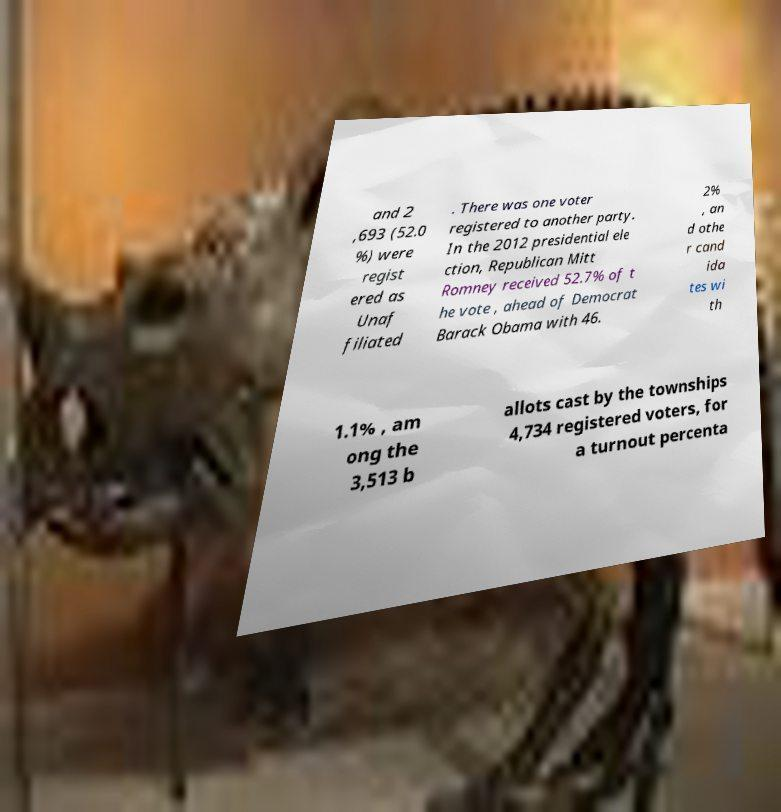Please identify and transcribe the text found in this image. and 2 ,693 (52.0 %) were regist ered as Unaf filiated . There was one voter registered to another party. In the 2012 presidential ele ction, Republican Mitt Romney received 52.7% of t he vote , ahead of Democrat Barack Obama with 46. 2% , an d othe r cand ida tes wi th 1.1% , am ong the 3,513 b allots cast by the townships 4,734 registered voters, for a turnout percenta 